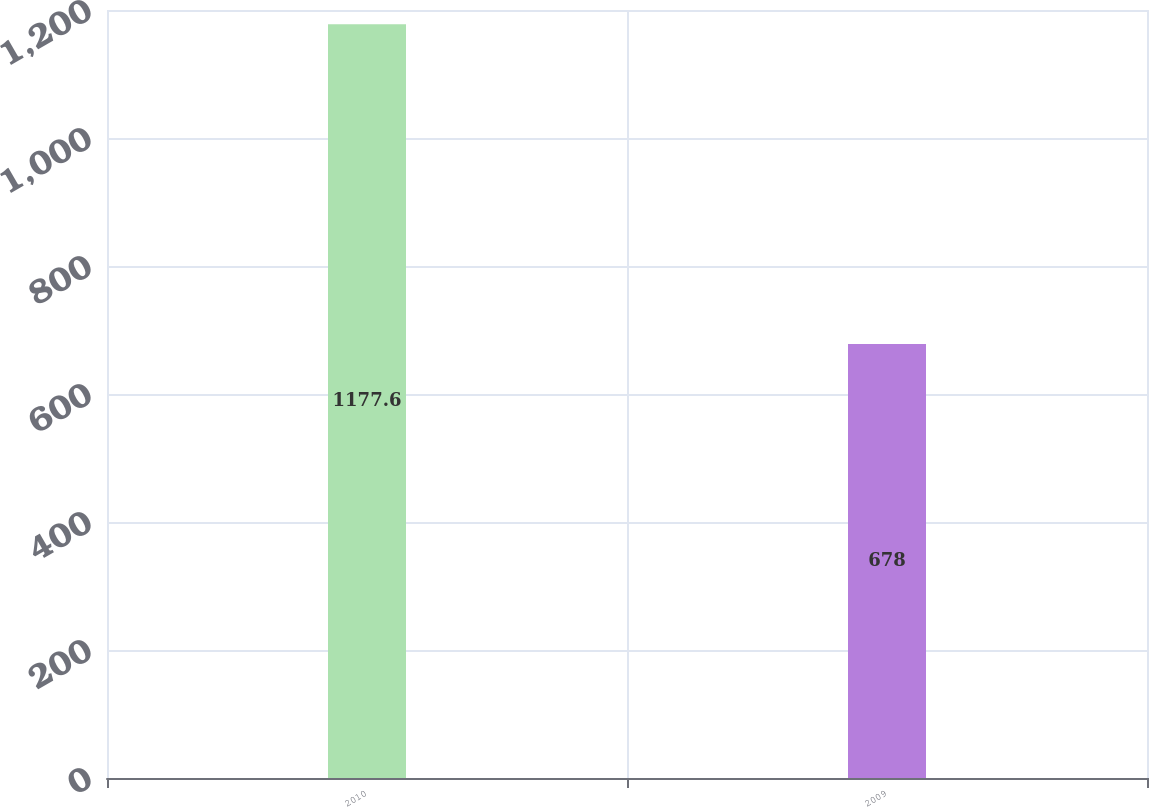Convert chart to OTSL. <chart><loc_0><loc_0><loc_500><loc_500><bar_chart><fcel>2010<fcel>2009<nl><fcel>1177.6<fcel>678<nl></chart> 